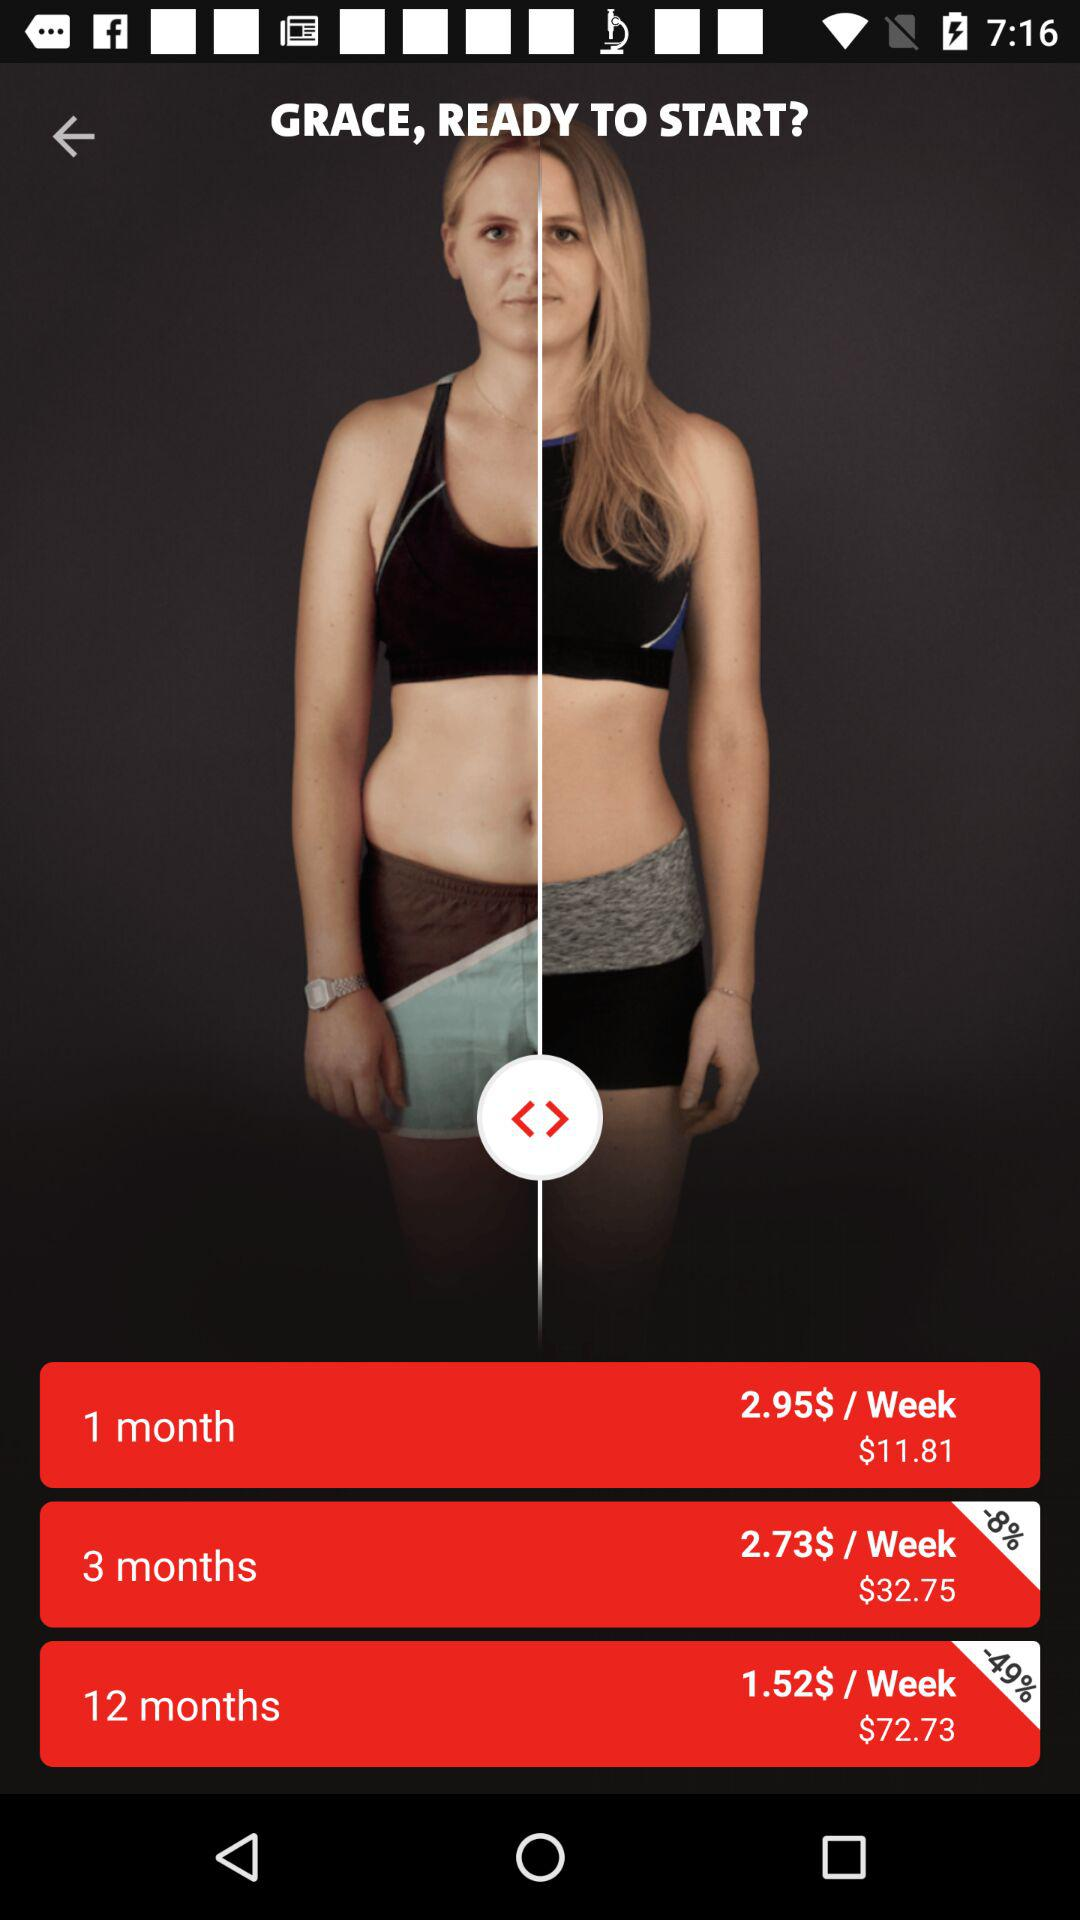How much is to be paid for 3 months? For 3 months, $32.75 is to be paid. 